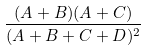<formula> <loc_0><loc_0><loc_500><loc_500>\frac { ( A + B ) ( A + C ) } { ( A + B + C + D ) ^ { 2 } }</formula> 